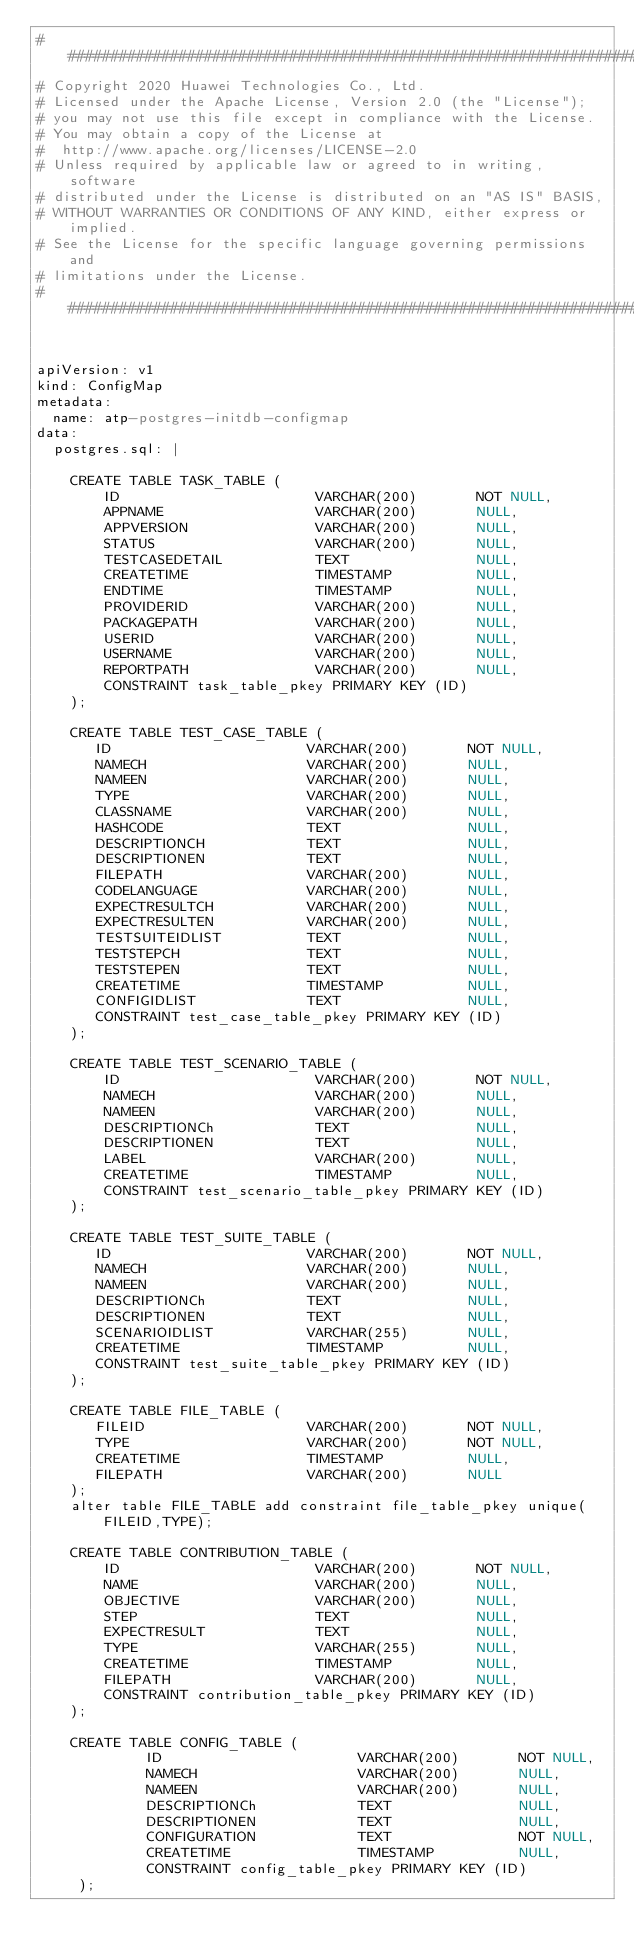Convert code to text. <code><loc_0><loc_0><loc_500><loc_500><_YAML_>###########################################################################
# Copyright 2020 Huawei Technologies Co., Ltd.
# Licensed under the Apache License, Version 2.0 (the "License");
# you may not use this file except in compliance with the License.
# You may obtain a copy of the License at
#  http://www.apache.org/licenses/LICENSE-2.0
# Unless required by applicable law or agreed to in writing, software
# distributed under the License is distributed on an "AS IS" BASIS,
# WITHOUT WARRANTIES OR CONDITIONS OF ANY KIND, either express or implied.
# See the License for the specific language governing permissions and
# limitations under the License.
############################################################################


apiVersion: v1
kind: ConfigMap
metadata:
  name: atp-postgres-initdb-configmap
data:
  postgres.sql: |

    CREATE TABLE TASK_TABLE (
        ID                       VARCHAR(200)       NOT NULL,
        APPNAME                  VARCHAR(200)       NULL,
        APPVERSION               VARCHAR(200)       NULL,
        STATUS                   VARCHAR(200)       NULL,
        TESTCASEDETAIL           TEXT               NULL,
        CREATETIME               TIMESTAMP          NULL,
        ENDTIME                  TIMESTAMP          NULL,
        PROVIDERID               VARCHAR(200)       NULL,
        PACKAGEPATH              VARCHAR(200)       NULL,
        USERID                   VARCHAR(200)       NULL,
        USERNAME                 VARCHAR(200)       NULL,
        REPORTPATH               VARCHAR(200)       NULL,
        CONSTRAINT task_table_pkey PRIMARY KEY (ID)
    );

    CREATE TABLE TEST_CASE_TABLE (
       ID                       VARCHAR(200)       NOT NULL,
       NAMECH                   VARCHAR(200)       NULL,
       NAMEEN                   VARCHAR(200)       NULL,
       TYPE                     VARCHAR(200)       NULL,
       CLASSNAME                VARCHAR(200)       NULL,
       HASHCODE                 TEXT               NULL, 
       DESCRIPTIONCH            TEXT               NULL,
       DESCRIPTIONEN            TEXT               NULL,
       FILEPATH                 VARCHAR(200)       NULL,
       CODELANGUAGE             VARCHAR(200)       NULL,
       EXPECTRESULTCH           VARCHAR(200)       NULL,
       EXPECTRESULTEN           VARCHAR(200)       NULL,
       TESTSUITEIDLIST          TEXT               NULL,
       TESTSTEPCH               TEXT               NULL,
       TESTSTEPEN               TEXT               NULL,
       CREATETIME               TIMESTAMP          NULL,
       CONFIGIDLIST             TEXT               NULL,
       CONSTRAINT test_case_table_pkey PRIMARY KEY (ID)
    );

    CREATE TABLE TEST_SCENARIO_TABLE (
        ID                       VARCHAR(200)       NOT NULL,
        NAMECH                   VARCHAR(200)       NULL,
        NAMEEN                   VARCHAR(200)       NULL,
        DESCRIPTIONCh            TEXT               NULL,
        DESCRIPTIONEN            TEXT               NULL,
        LABEL                    VARCHAR(200)       NULL,
        CREATETIME               TIMESTAMP          NULL,
        CONSTRAINT test_scenario_table_pkey PRIMARY KEY (ID)
    );

    CREATE TABLE TEST_SUITE_TABLE (
       ID                       VARCHAR(200)       NOT NULL,
       NAMECH                   VARCHAR(200)       NULL,
       NAMEEN                   VARCHAR(200)       NULL,
       DESCRIPTIONCh            TEXT               NULL,
       DESCRIPTIONEN            TEXT               NULL, 
       SCENARIOIDLIST           VARCHAR(255)       NULL,
       CREATETIME               TIMESTAMP          NULL,
       CONSTRAINT test_suite_table_pkey PRIMARY KEY (ID)
    );

    CREATE TABLE FILE_TABLE (
       FILEID                   VARCHAR(200)       NOT NULL,
       TYPE                     VARCHAR(200)       NOT NULL,
       CREATETIME               TIMESTAMP          NULL,
       FILEPATH                 VARCHAR(200)       NULL
    );
    alter table FILE_TABLE add constraint file_table_pkey unique(FILEID,TYPE);

    CREATE TABLE CONTRIBUTION_TABLE (
        ID                       VARCHAR(200)       NOT NULL,
        NAME                     VARCHAR(200)       NULL,
        OBJECTIVE                VARCHAR(200)       NULL,
        STEP                     TEXT               NULL,
        EXPECTRESULT             TEXT               NULL, 
        TYPE                     VARCHAR(255)       NULL,
        CREATETIME               TIMESTAMP          NULL,
        FILEPATH                 VARCHAR(200)       NULL,
        CONSTRAINT contribution_table_pkey PRIMARY KEY (ID)
    );

    CREATE TABLE CONFIG_TABLE (
             ID                       VARCHAR(200)       NOT NULL,
             NAMECH                   VARCHAR(200)       NULL,
             NAMEEN                   VARCHAR(200)       NULL,
             DESCRIPTIONCh            TEXT               NULL,
             DESCRIPTIONEN            TEXT               NULL,
             CONFIGURATION            TEXT               NOT NULL,
             CREATETIME               TIMESTAMP          NULL,
             CONSTRAINT config_table_pkey PRIMARY KEY (ID)
     );</code> 